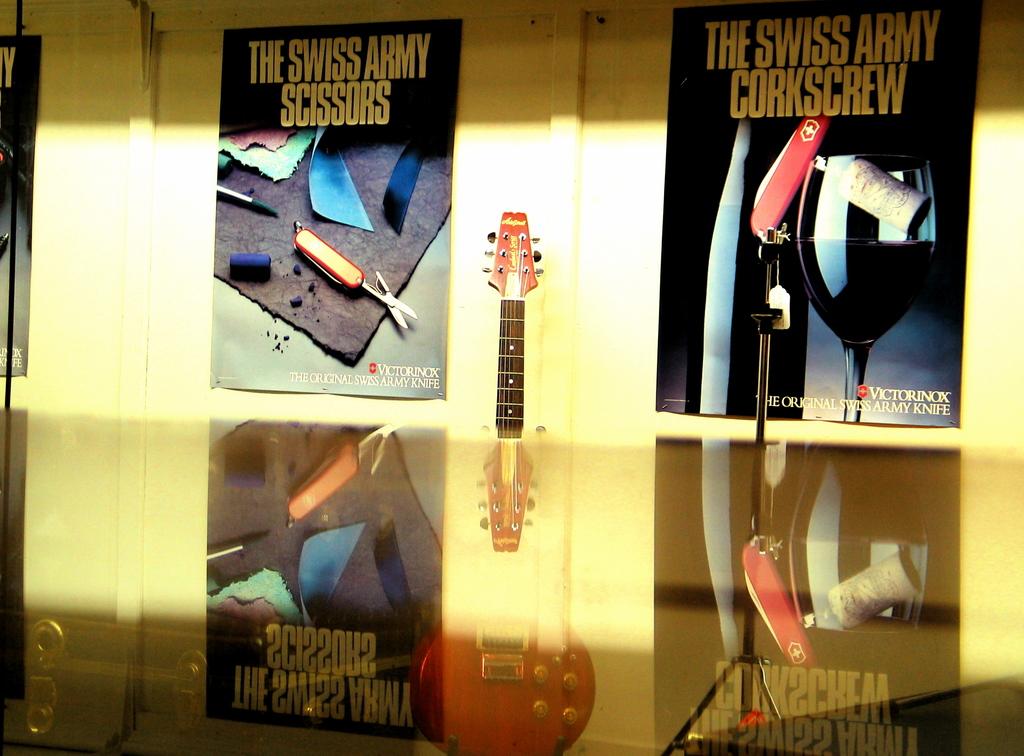What types of swiss army products are there?
Offer a very short reply. Scissors and corkscrew. 